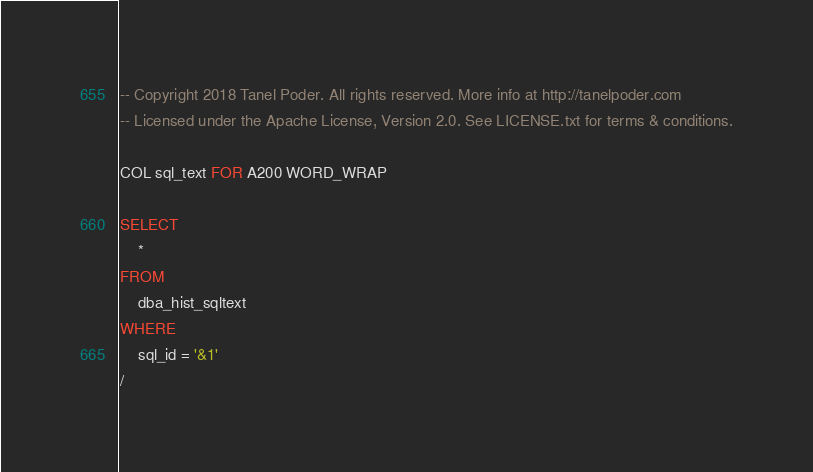<code> <loc_0><loc_0><loc_500><loc_500><_SQL_>-- Copyright 2018 Tanel Poder. All rights reserved. More info at http://tanelpoder.com
-- Licensed under the Apache License, Version 2.0. See LICENSE.txt for terms & conditions.

COL sql_text FOR A200 WORD_WRAP

SELECT
    *
FROM
    dba_hist_sqltext
WHERE
    sql_id = '&1'
/
</code> 